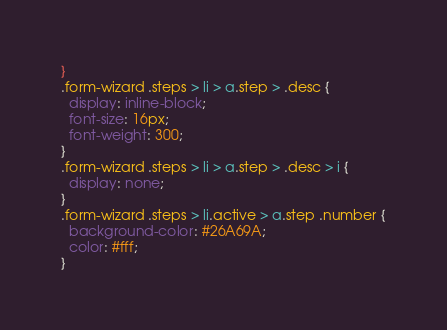Convert code to text. <code><loc_0><loc_0><loc_500><loc_500><_CSS_>}
.form-wizard .steps > li > a.step > .desc {
  display: inline-block;
  font-size: 16px;
  font-weight: 300;
}
.form-wizard .steps > li > a.step > .desc > i {
  display: none;
}
.form-wizard .steps > li.active > a.step .number {
  background-color: #26A69A;
  color: #fff;
}</code> 